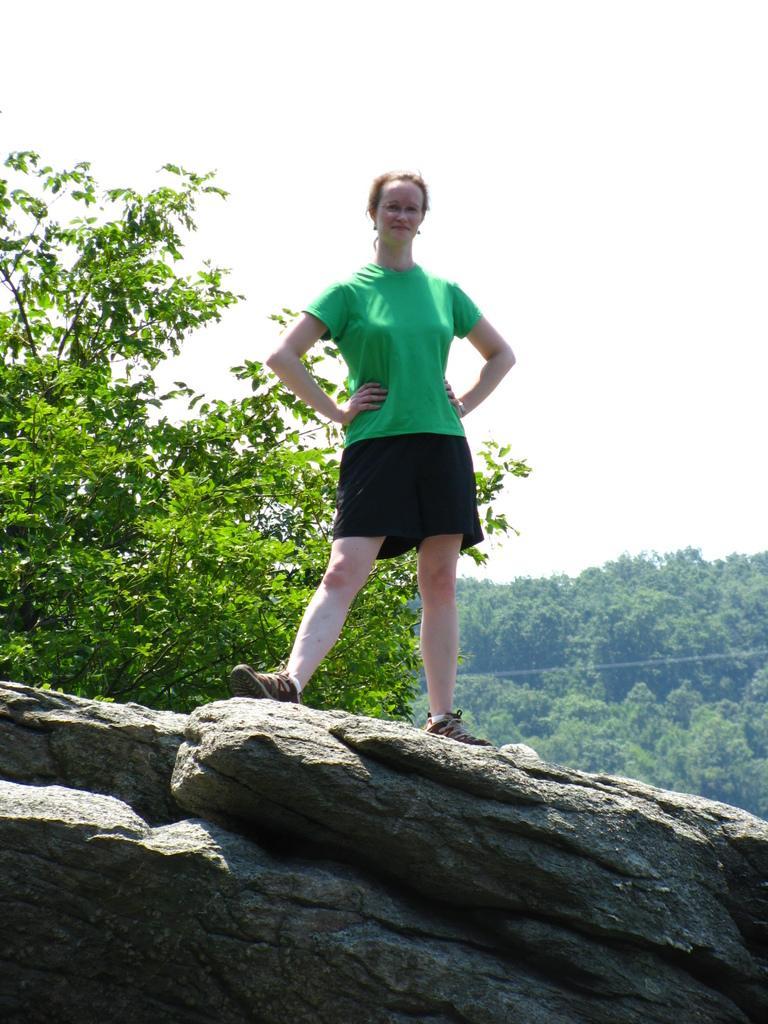Could you give a brief overview of what you see in this image? In this picture there is a woman who is wearing green t-shirt, short and shoe. She is standing on the stone. On the back we can see many trees. On the top there is a sky. 